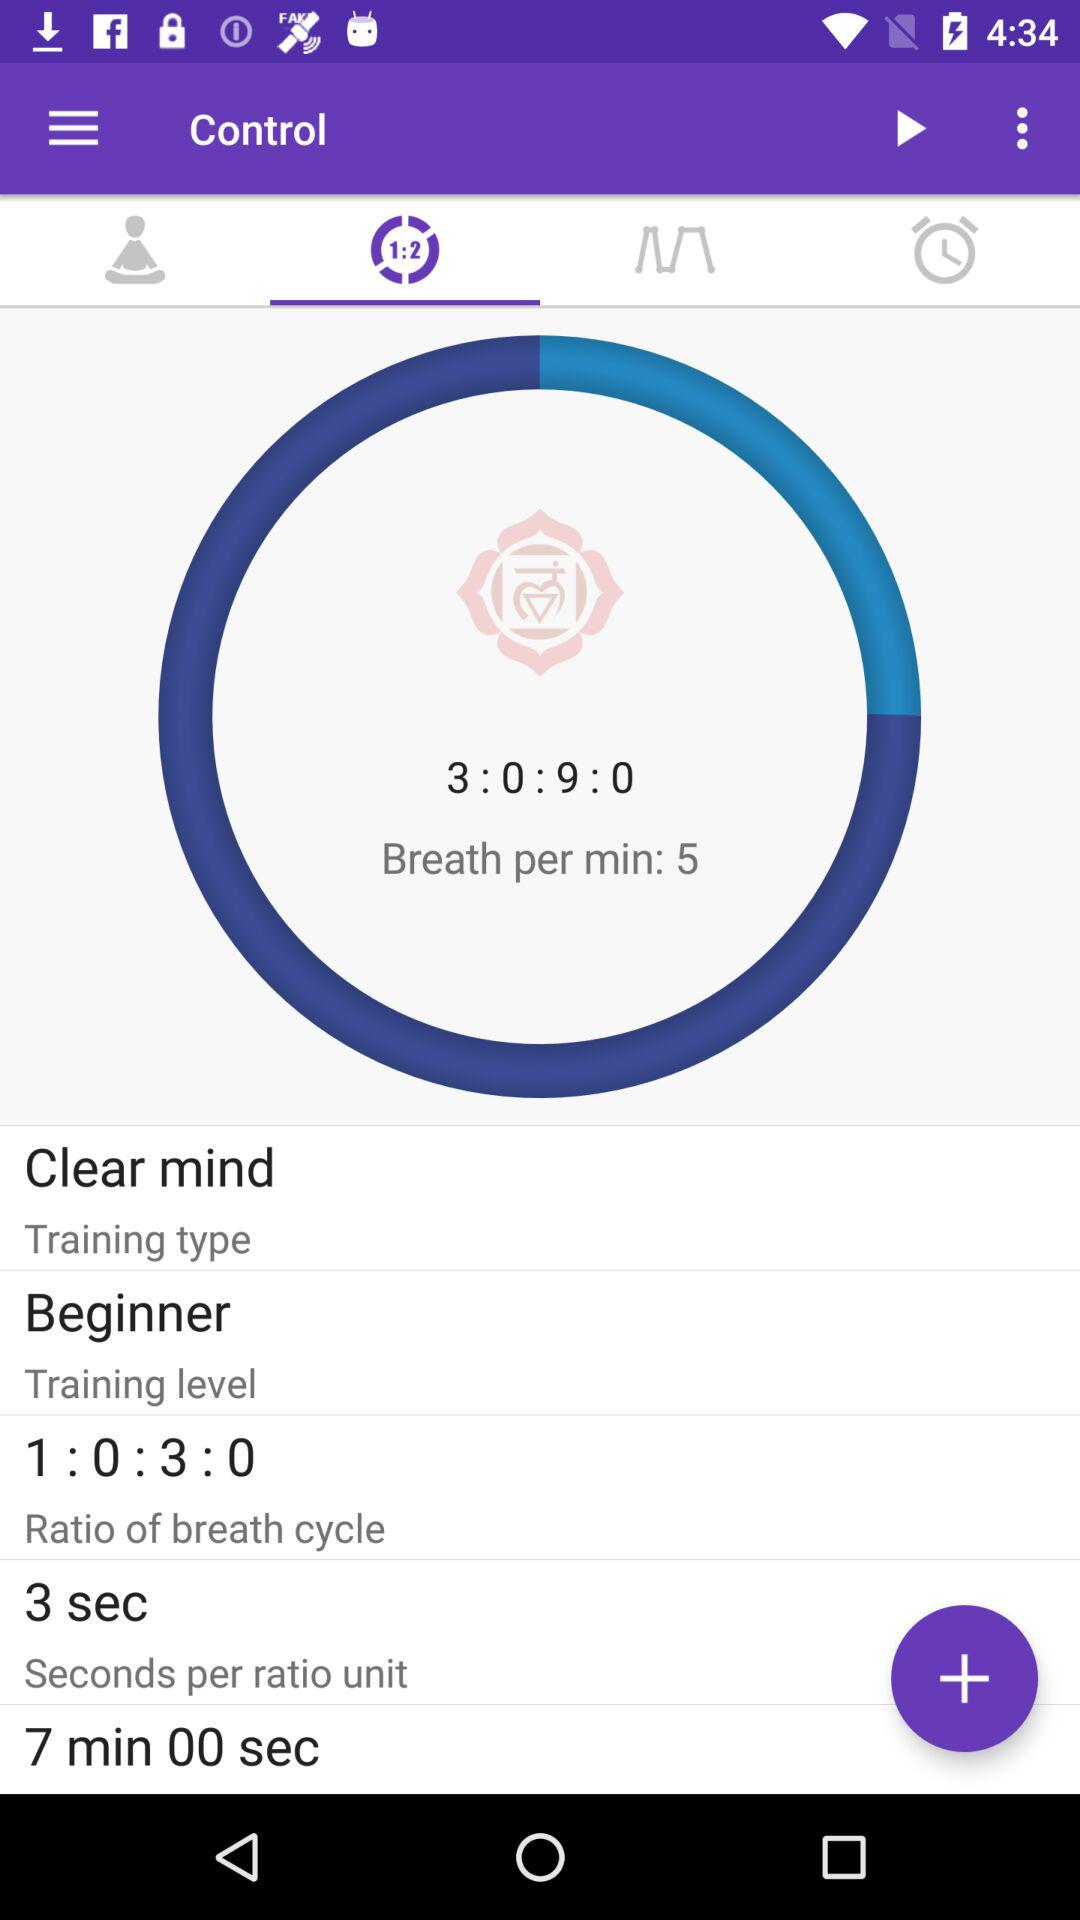What is the training level? The training level is beginner. 